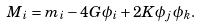<formula> <loc_0><loc_0><loc_500><loc_500>M _ { i } = m _ { i } - 4 G \phi _ { i } + 2 K \phi _ { j } \, \phi _ { k } .</formula> 